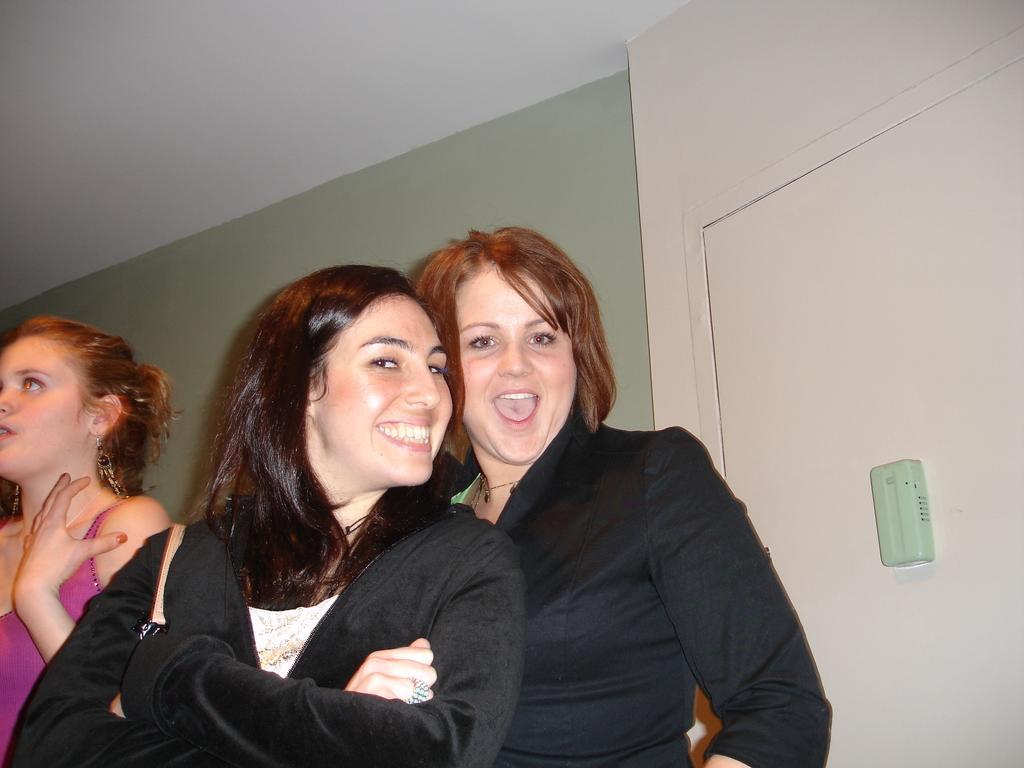Describe this image in one or two sentences. In this picture we can see two women smiling. There is a green object on a white surface. A person is visible on the left side. A wall is visible in the background. 